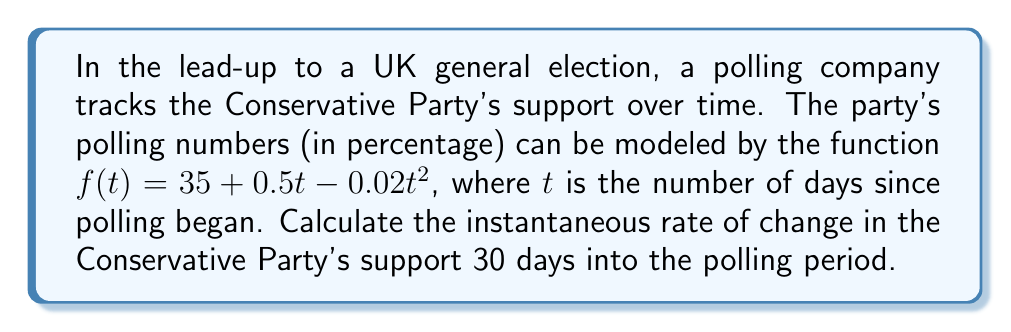Help me with this question. To find the instantaneous rate of change, we need to calculate the derivative of the given function and evaluate it at $t = 30$.

1. Given function: $f(t) = 35 + 0.5t - 0.02t^2$

2. Calculate the derivative:
   $f'(t) = \frac{d}{dt}(35 + 0.5t - 0.02t^2)$
   $f'(t) = 0 + 0.5 - 0.04t$ (using the power rule)
   $f'(t) = 0.5 - 0.04t$

3. Evaluate the derivative at $t = 30$:
   $f'(30) = 0.5 - 0.04(30)$
   $f'(30) = 0.5 - 1.2$
   $f'(30) = -0.7$

The negative value indicates that the Conservative Party's support is decreasing at this point in time.
Answer: $-0.7$ percentage points per day 